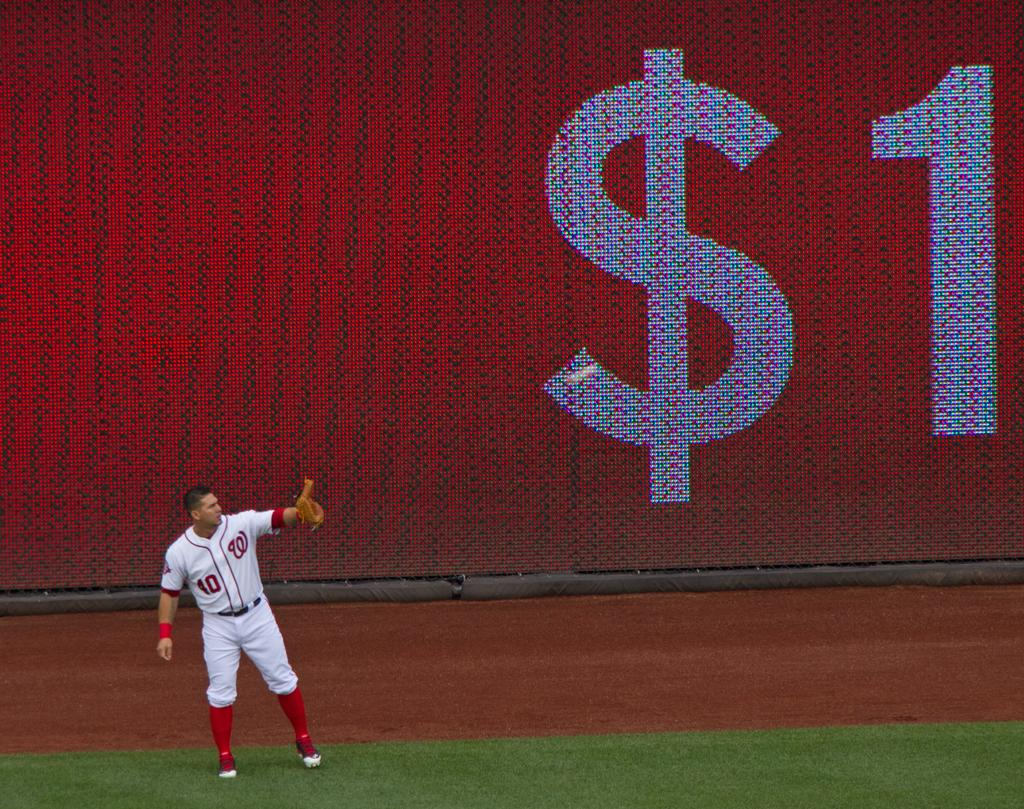What type of vegetation is present on the ground in the image? There is grass on the ground in the front of the image. What is the main subject in the center of the image? There is a man standing in the center of the image. What can be seen in the background of the image? There is a board with symbols and numbers written on it in the background of the image. Can you see a zebra grazing on the grass in the image? There is no zebra present in the image; it features grass, a man, and a board with symbols and numbers. What type of poison is the man holding in the image? There is no poison present in the image; the man is standing in the center of the image without any visible objects in his hands. 